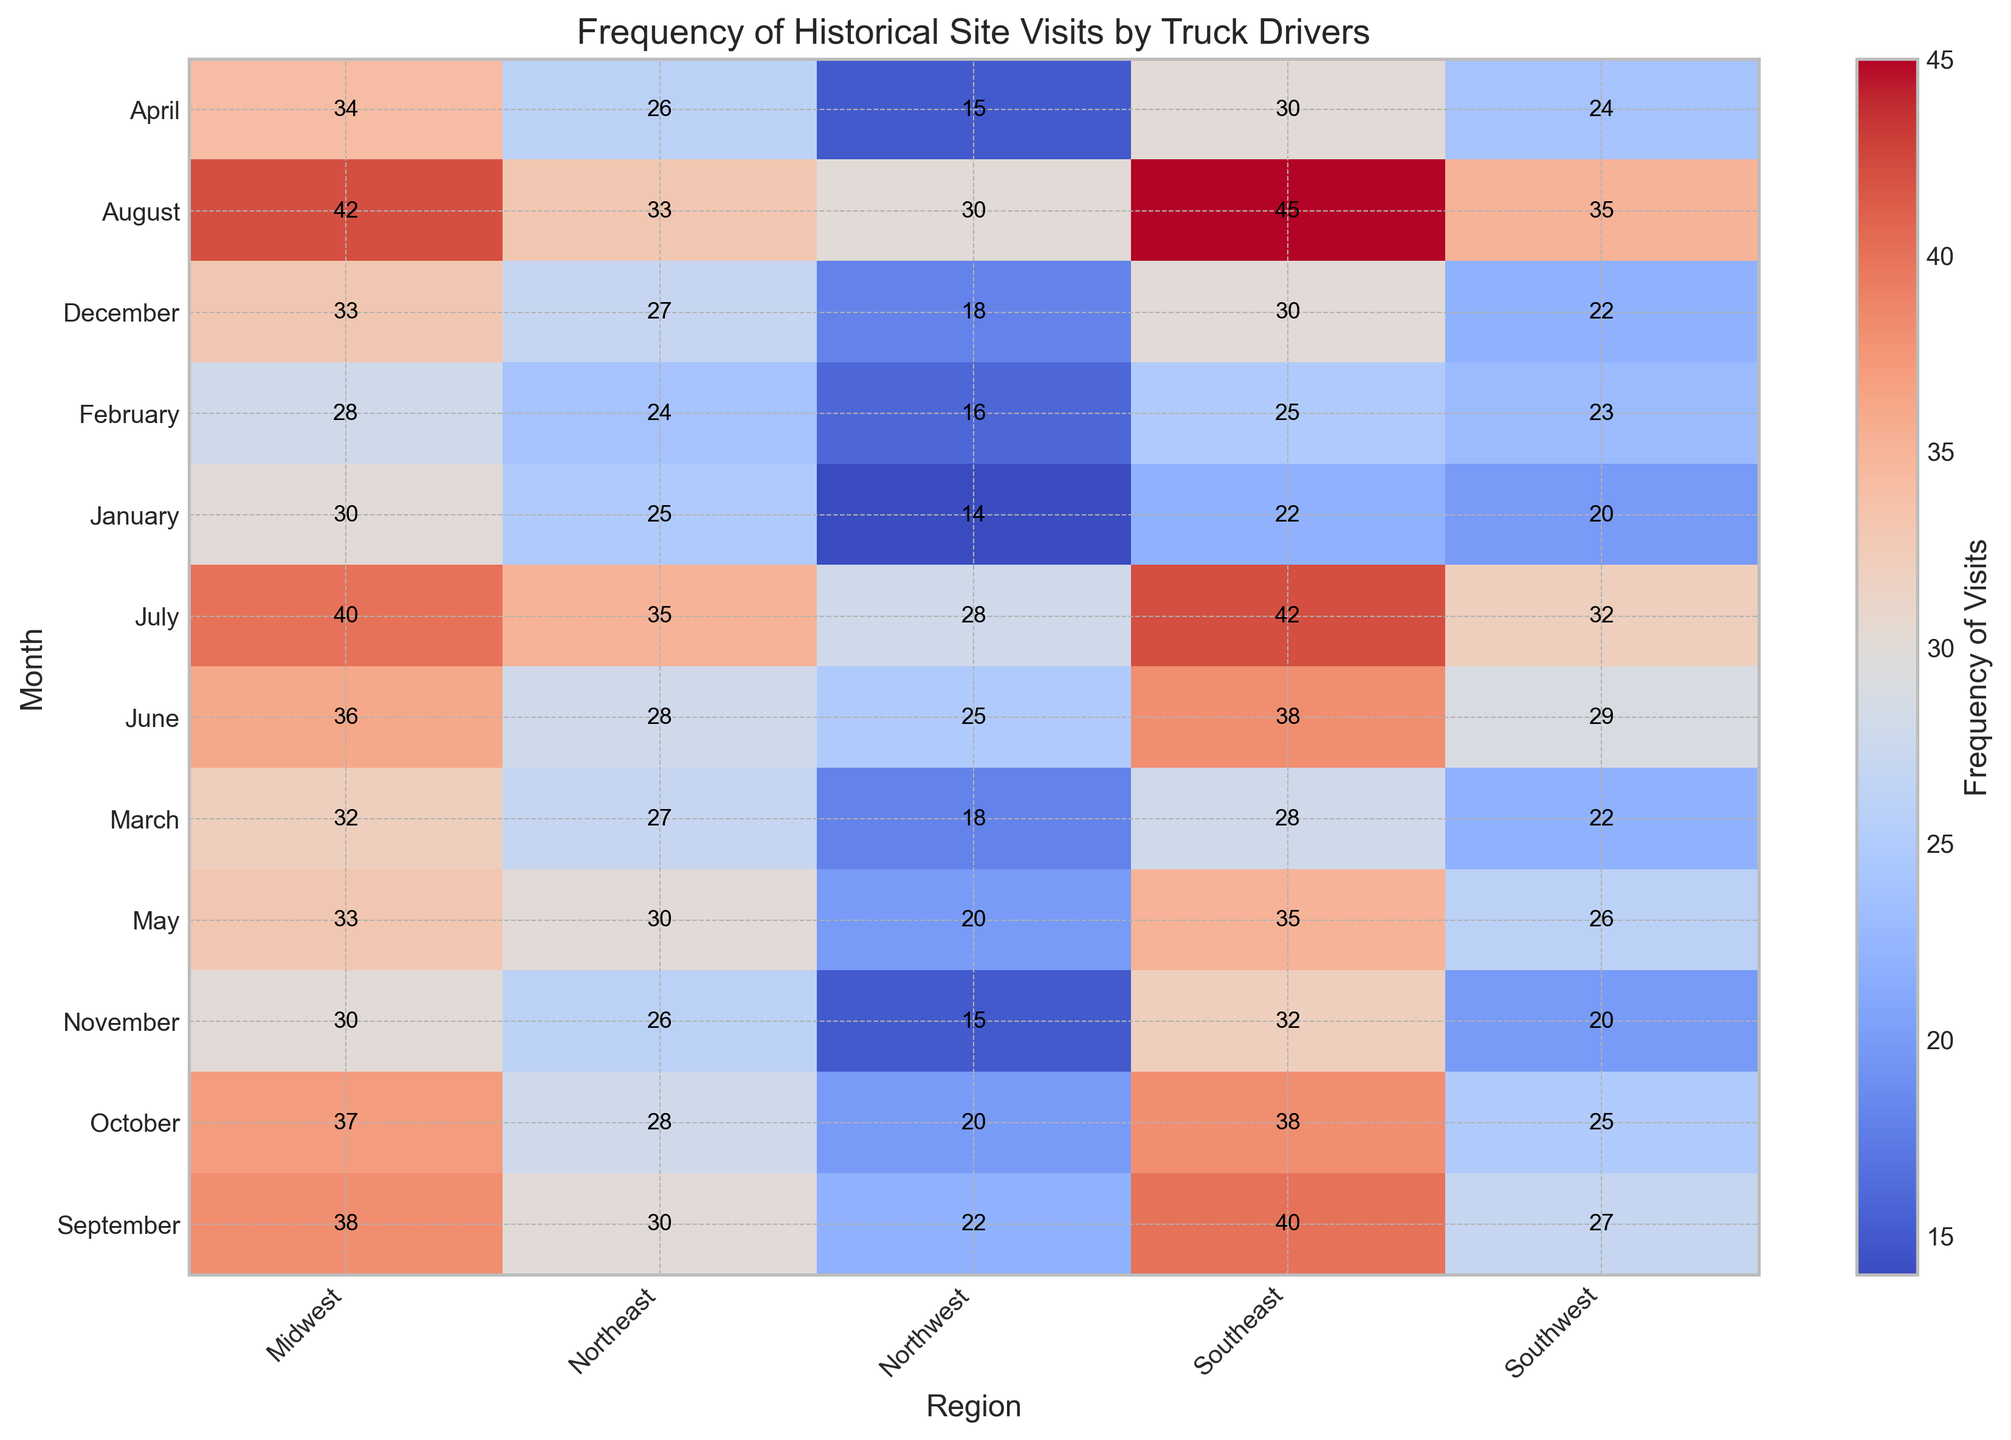Which month has the highest overall frequency of historical site visits? By examining the color intensity across all regions for each month, we see that August has the most saturated colors, signifying the highest frequencies. A quick review of the data confirms that August has high visitation numbers across all regions.
Answer: August In which region and month is the lowest frequency of visits recorded? Identify the cell with the lightest color. January in the Northwest region shows the lightest color, confirmed by a frequency of 14.
Answer: January, Northwest What is the average frequency of visits in the Midwest region across all months? Sum the frequencies for the Midwest region (30, 28, 32, 34, 33, 36, 40, 42, 38, 37, 30, 33) and divide by 12. The calculations are (30+28+32+34+33+36+40+42+38+37+30+33) = 413, followed by 413 / 12 = 34.42.
Answer: 34.42 Which region sees the greatest monthly increase in visits from February to March? Compare the frequency difference for each region between February and March. The Northwest increases by 2 (16 to 18), Southwest by -1 (23 to 22), Midwest by 4 (28 to 32), Northeast by 3 (24 to 27), and Southeast by 3 (25 to 28). Midwest has the highest increase of 4.
Answer: Midwest Compare the frequency of visits in July for the Midwest and Northeast regions. Which one has a higher frequency and by how much? Look at July values: Midwest has 40, and Northeast has 35. The Midwest has 5 more visits than the Northeast (40 - 35 = 5).
Answer: Midwest, by 5 Are the visit frequencies in the Southeast region generally higher or lower than those in the Northwest region across the year? Compare the color shades and values month by month. Southeast has higher frequencies than Northwest in almost every month (except January and November where numbers are closer or identical).
Answer: Generally higher What is the most surprising month-to-month variation in the Southwest region? Look for significant color changes. July to August shows a prominent increase in frequency (32 to 35), which is relatively notable compared to other months.
Answer: July to August If combining the first three months' data for the Northeast region, what is the total frequency? Sum the frequencies for January, February, and March in the Northeast (25 + 24 + 27). This yields (25 + 24 + 27) = 76.
Answer: 76 What month and region combination shows the highest increase directly following the month with the lowest frequency? The lowest frequency is recorded in January for the Northwest (14). The increase to February is (16 - 14) = 2. Compare this with other regions following their lowest frequency month. The highest increase from a low is in August for the Southeast (45 from 42 in July), with an increase of 3.
Answer: Following July in the Southeast with an increase of 3 